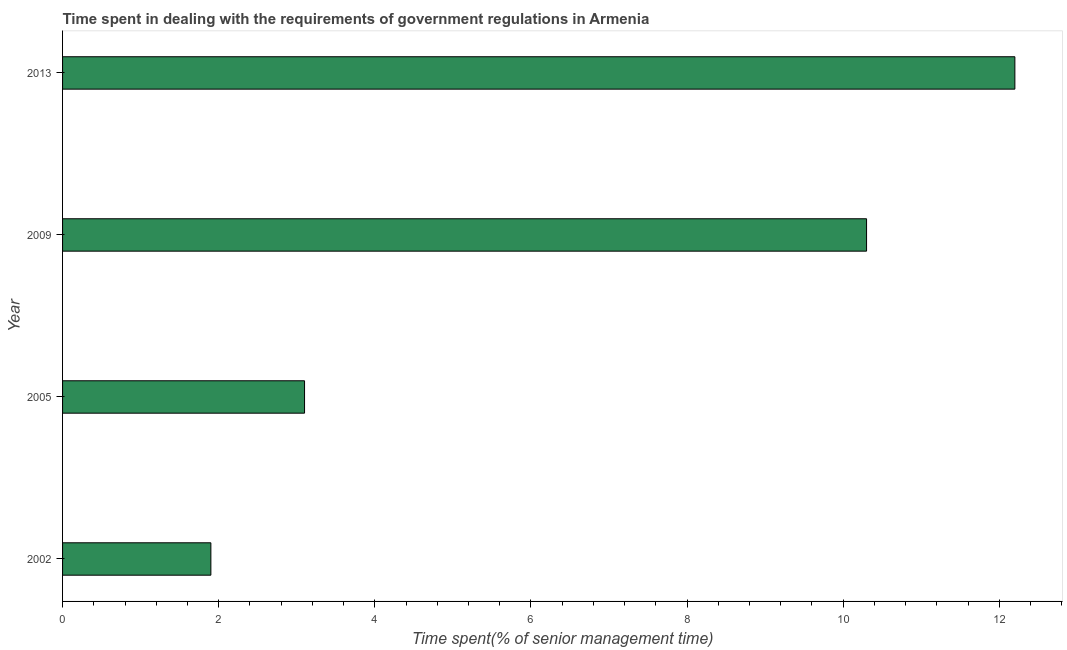What is the title of the graph?
Offer a terse response. Time spent in dealing with the requirements of government regulations in Armenia. What is the label or title of the X-axis?
Offer a very short reply. Time spent(% of senior management time). What is the label or title of the Y-axis?
Provide a succinct answer. Year. What is the time spent in dealing with government regulations in 2002?
Your answer should be compact. 1.9. Across all years, what is the minimum time spent in dealing with government regulations?
Give a very brief answer. 1.9. In which year was the time spent in dealing with government regulations maximum?
Your response must be concise. 2013. In which year was the time spent in dealing with government regulations minimum?
Provide a short and direct response. 2002. What is the average time spent in dealing with government regulations per year?
Provide a short and direct response. 6.88. Do a majority of the years between 2009 and 2005 (inclusive) have time spent in dealing with government regulations greater than 3.2 %?
Your response must be concise. No. What is the ratio of the time spent in dealing with government regulations in 2005 to that in 2009?
Provide a succinct answer. 0.3. Is the difference between the time spent in dealing with government regulations in 2005 and 2013 greater than the difference between any two years?
Provide a short and direct response. No. What is the difference between the highest and the second highest time spent in dealing with government regulations?
Provide a succinct answer. 1.9. How many bars are there?
Offer a terse response. 4. How many years are there in the graph?
Provide a succinct answer. 4. Are the values on the major ticks of X-axis written in scientific E-notation?
Offer a very short reply. No. What is the Time spent(% of senior management time) of 2002?
Your answer should be compact. 1.9. What is the Time spent(% of senior management time) in 2005?
Your answer should be compact. 3.1. What is the Time spent(% of senior management time) in 2013?
Keep it short and to the point. 12.2. What is the difference between the Time spent(% of senior management time) in 2002 and 2013?
Ensure brevity in your answer.  -10.3. What is the ratio of the Time spent(% of senior management time) in 2002 to that in 2005?
Offer a terse response. 0.61. What is the ratio of the Time spent(% of senior management time) in 2002 to that in 2009?
Your response must be concise. 0.18. What is the ratio of the Time spent(% of senior management time) in 2002 to that in 2013?
Offer a very short reply. 0.16. What is the ratio of the Time spent(% of senior management time) in 2005 to that in 2009?
Ensure brevity in your answer.  0.3. What is the ratio of the Time spent(% of senior management time) in 2005 to that in 2013?
Ensure brevity in your answer.  0.25. What is the ratio of the Time spent(% of senior management time) in 2009 to that in 2013?
Ensure brevity in your answer.  0.84. 